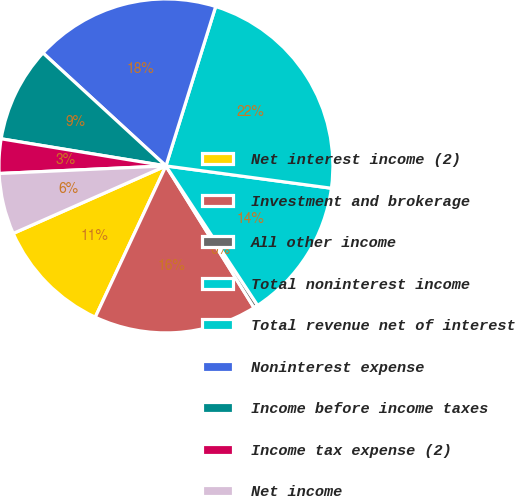<chart> <loc_0><loc_0><loc_500><loc_500><pie_chart><fcel>Net interest income (2)<fcel>Investment and brokerage<fcel>All other income<fcel>Total noninterest income<fcel>Total revenue net of interest<fcel>Noninterest expense<fcel>Income before income taxes<fcel>Income tax expense (2)<fcel>Net income<nl><fcel>11.42%<fcel>15.8%<fcel>0.41%<fcel>13.61%<fcel>22.32%<fcel>17.99%<fcel>9.23%<fcel>3.32%<fcel>5.9%<nl></chart> 